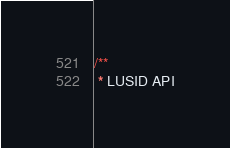<code> <loc_0><loc_0><loc_500><loc_500><_TypeScript_>/**
 * LUSID API</code> 